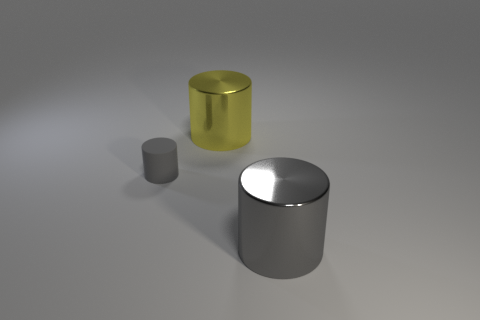Add 3 tiny brown shiny cylinders. How many objects exist? 6 Subtract all tiny yellow shiny blocks. Subtract all small gray cylinders. How many objects are left? 2 Add 3 metal things. How many metal things are left? 5 Add 2 big yellow metallic cylinders. How many big yellow metallic cylinders exist? 3 Subtract 0 cyan blocks. How many objects are left? 3 